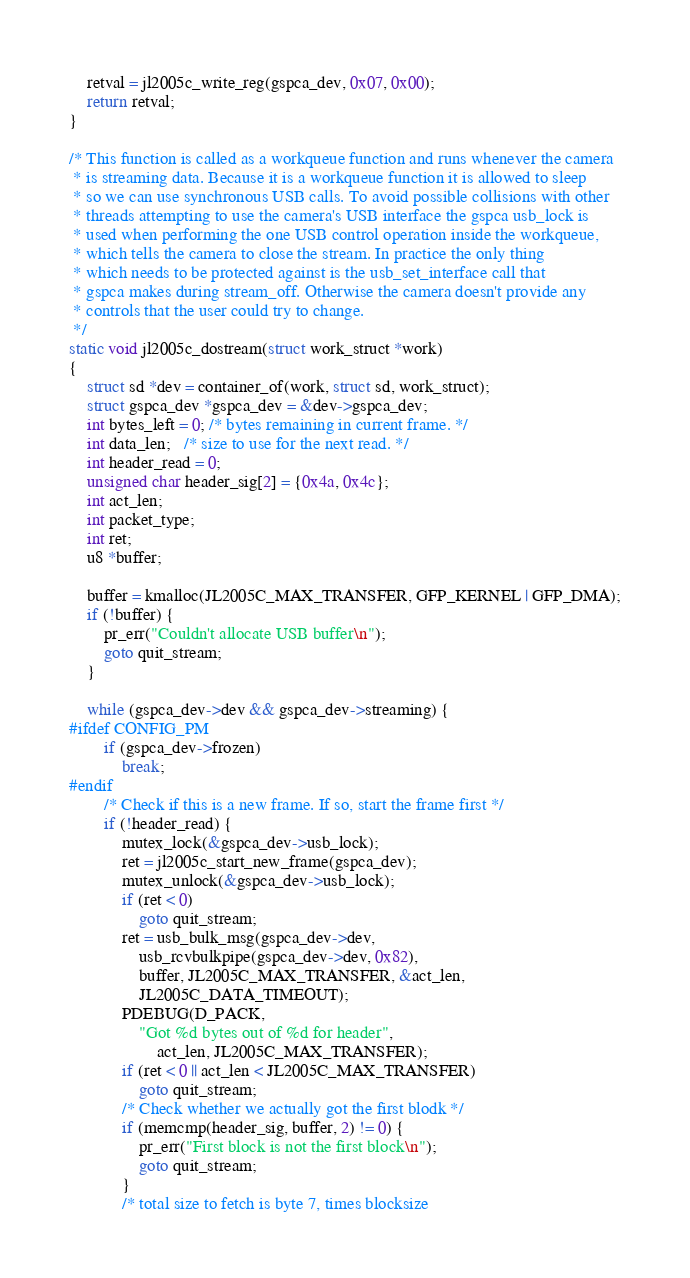Convert code to text. <code><loc_0><loc_0><loc_500><loc_500><_C_>
	retval = jl2005c_write_reg(gspca_dev, 0x07, 0x00);
	return retval;
}

/* This function is called as a workqueue function and runs whenever the camera
 * is streaming data. Because it is a workqueue function it is allowed to sleep
 * so we can use synchronous USB calls. To avoid possible collisions with other
 * threads attempting to use the camera's USB interface the gspca usb_lock is
 * used when performing the one USB control operation inside the workqueue,
 * which tells the camera to close the stream. In practice the only thing
 * which needs to be protected against is the usb_set_interface call that
 * gspca makes during stream_off. Otherwise the camera doesn't provide any
 * controls that the user could try to change.
 */
static void jl2005c_dostream(struct work_struct *work)
{
	struct sd *dev = container_of(work, struct sd, work_struct);
	struct gspca_dev *gspca_dev = &dev->gspca_dev;
	int bytes_left = 0; /* bytes remaining in current frame. */
	int data_len;   /* size to use for the next read. */
	int header_read = 0;
	unsigned char header_sig[2] = {0x4a, 0x4c};
	int act_len;
	int packet_type;
	int ret;
	u8 *buffer;

	buffer = kmalloc(JL2005C_MAX_TRANSFER, GFP_KERNEL | GFP_DMA);
	if (!buffer) {
		pr_err("Couldn't allocate USB buffer\n");
		goto quit_stream;
	}

	while (gspca_dev->dev && gspca_dev->streaming) {
#ifdef CONFIG_PM
		if (gspca_dev->frozen)
			break;
#endif
		/* Check if this is a new frame. If so, start the frame first */
		if (!header_read) {
			mutex_lock(&gspca_dev->usb_lock);
			ret = jl2005c_start_new_frame(gspca_dev);
			mutex_unlock(&gspca_dev->usb_lock);
			if (ret < 0)
				goto quit_stream;
			ret = usb_bulk_msg(gspca_dev->dev,
				usb_rcvbulkpipe(gspca_dev->dev, 0x82),
				buffer, JL2005C_MAX_TRANSFER, &act_len,
				JL2005C_DATA_TIMEOUT);
			PDEBUG(D_PACK,
				"Got %d bytes out of %d for header",
					act_len, JL2005C_MAX_TRANSFER);
			if (ret < 0 || act_len < JL2005C_MAX_TRANSFER)
				goto quit_stream;
			/* Check whether we actually got the first blodk */
			if (memcmp(header_sig, buffer, 2) != 0) {
				pr_err("First block is not the first block\n");
				goto quit_stream;
			}
			/* total size to fetch is byte 7, times blocksize</code> 